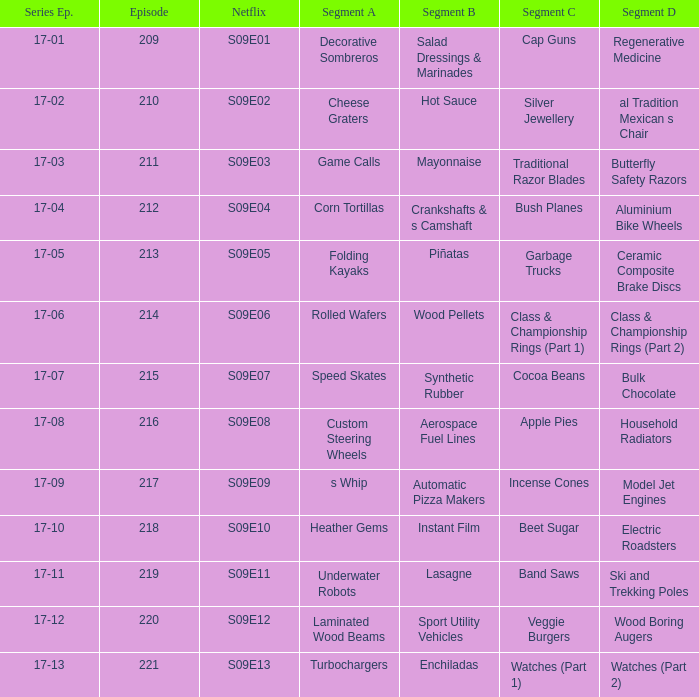Which netflix episode corresponds to segment b of aerospace fuel lines? S09E08. 